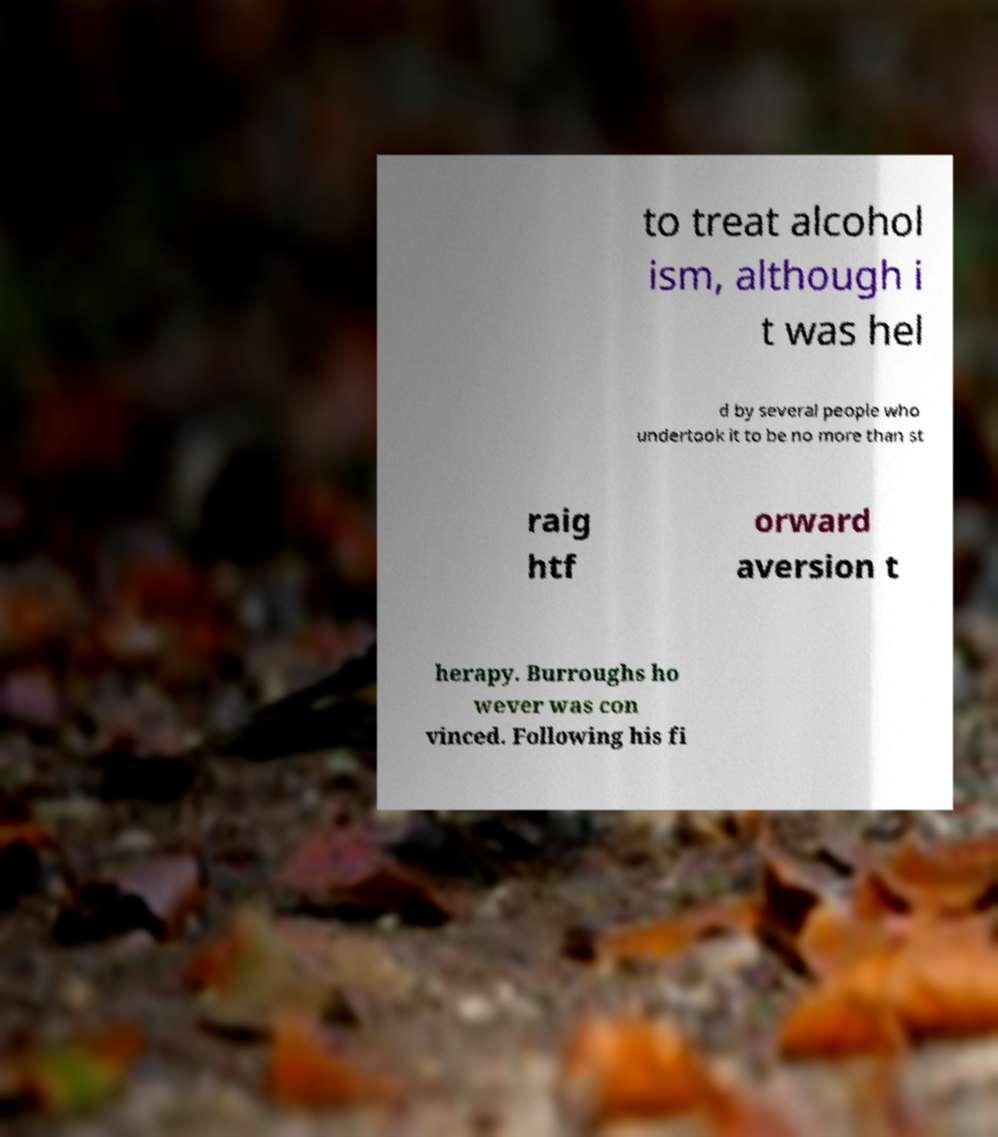Can you read and provide the text displayed in the image?This photo seems to have some interesting text. Can you extract and type it out for me? to treat alcohol ism, although i t was hel d by several people who undertook it to be no more than st raig htf orward aversion t herapy. Burroughs ho wever was con vinced. Following his fi 